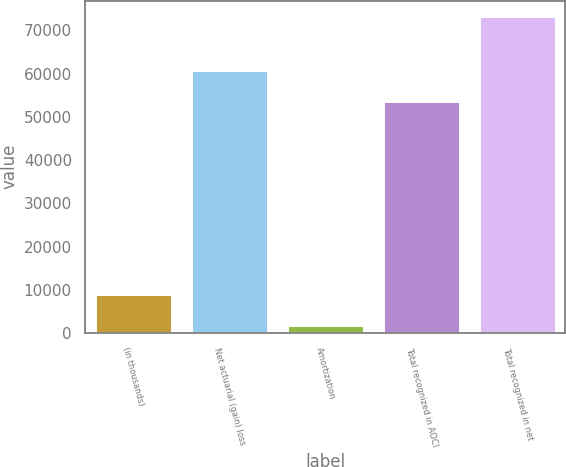Convert chart to OTSL. <chart><loc_0><loc_0><loc_500><loc_500><bar_chart><fcel>(in thousands)<fcel>Net actuarial (gain) loss<fcel>Amortization<fcel>Total recognized in AOCI<fcel>Total recognized in net<nl><fcel>8996.2<fcel>60783.2<fcel>1857<fcel>53644<fcel>73249<nl></chart> 